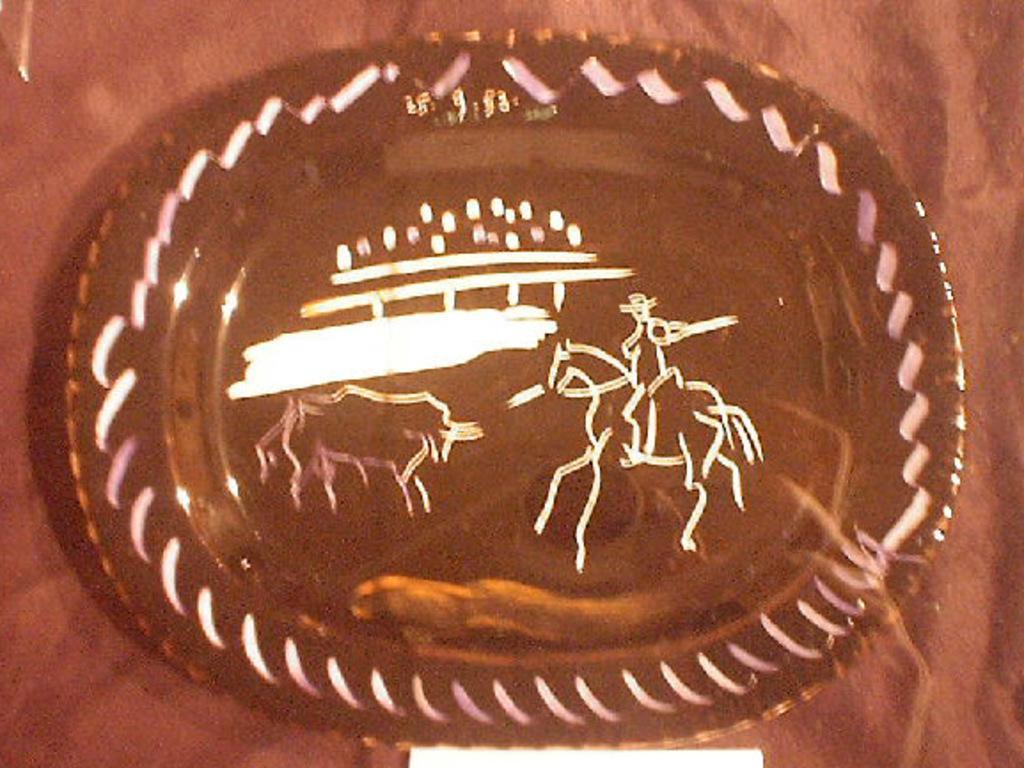Please provide a concise description of this image. In the center of the image we can see a plate placed on the table. 